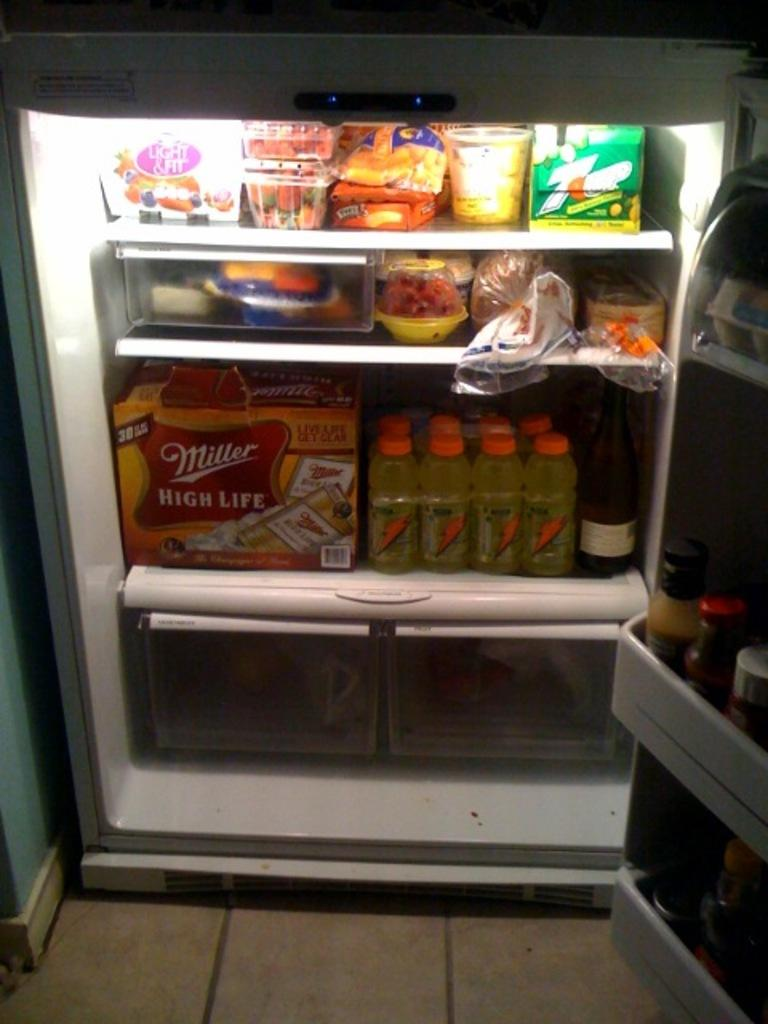<image>
Present a compact description of the photo's key features. A fridge with drinks such as Miller High Life 